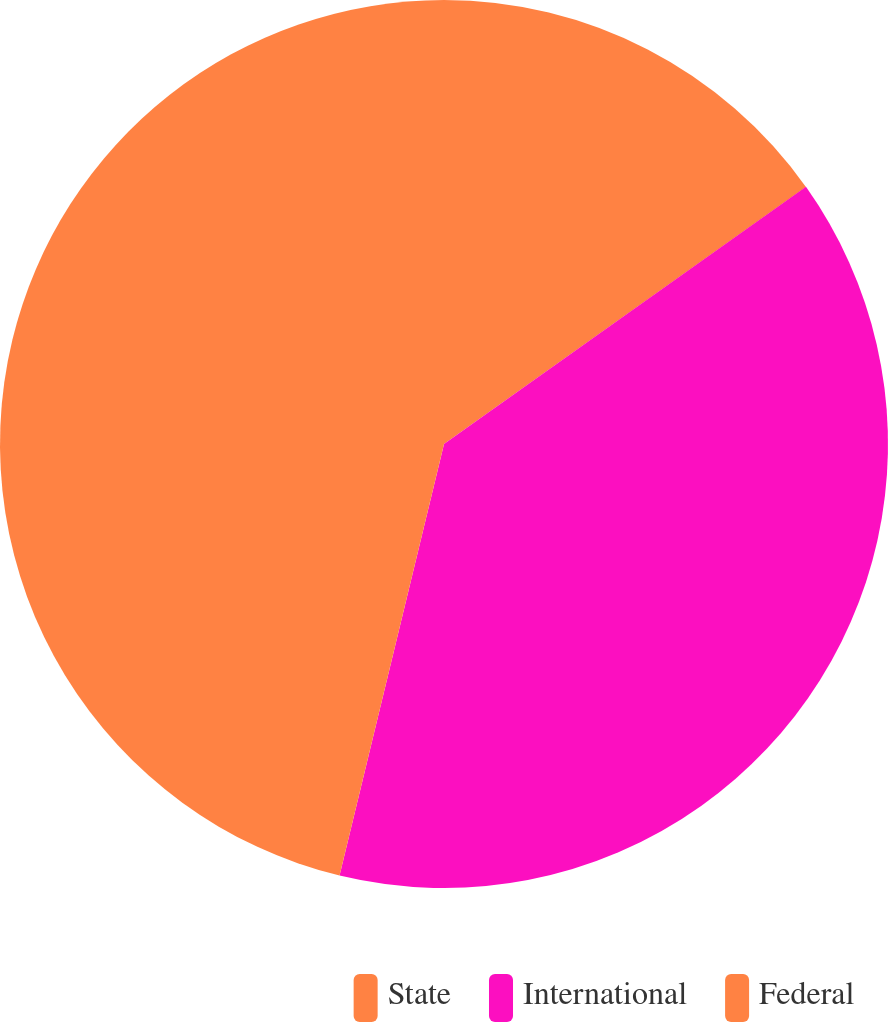Convert chart. <chart><loc_0><loc_0><loc_500><loc_500><pie_chart><fcel>State<fcel>International<fcel>Federal<nl><fcel>15.17%<fcel>38.61%<fcel>46.22%<nl></chart> 